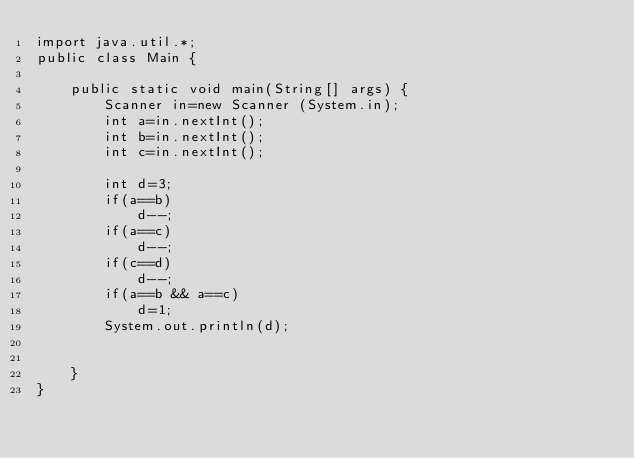Convert code to text. <code><loc_0><loc_0><loc_500><loc_500><_Java_>import java.util.*;
public class Main {
		
	public static void main(String[] args) {
		Scanner in=new Scanner (System.in);
		int a=in.nextInt();
		int b=in.nextInt();
		int c=in.nextInt();
		
		int d=3;
		if(a==b)
			d--;
		if(a==c)
			d--;
		if(c==d)
			d--;
		if(a==b && a==c)
			d=1;
		System.out.println(d);
		
		
	}
}</code> 